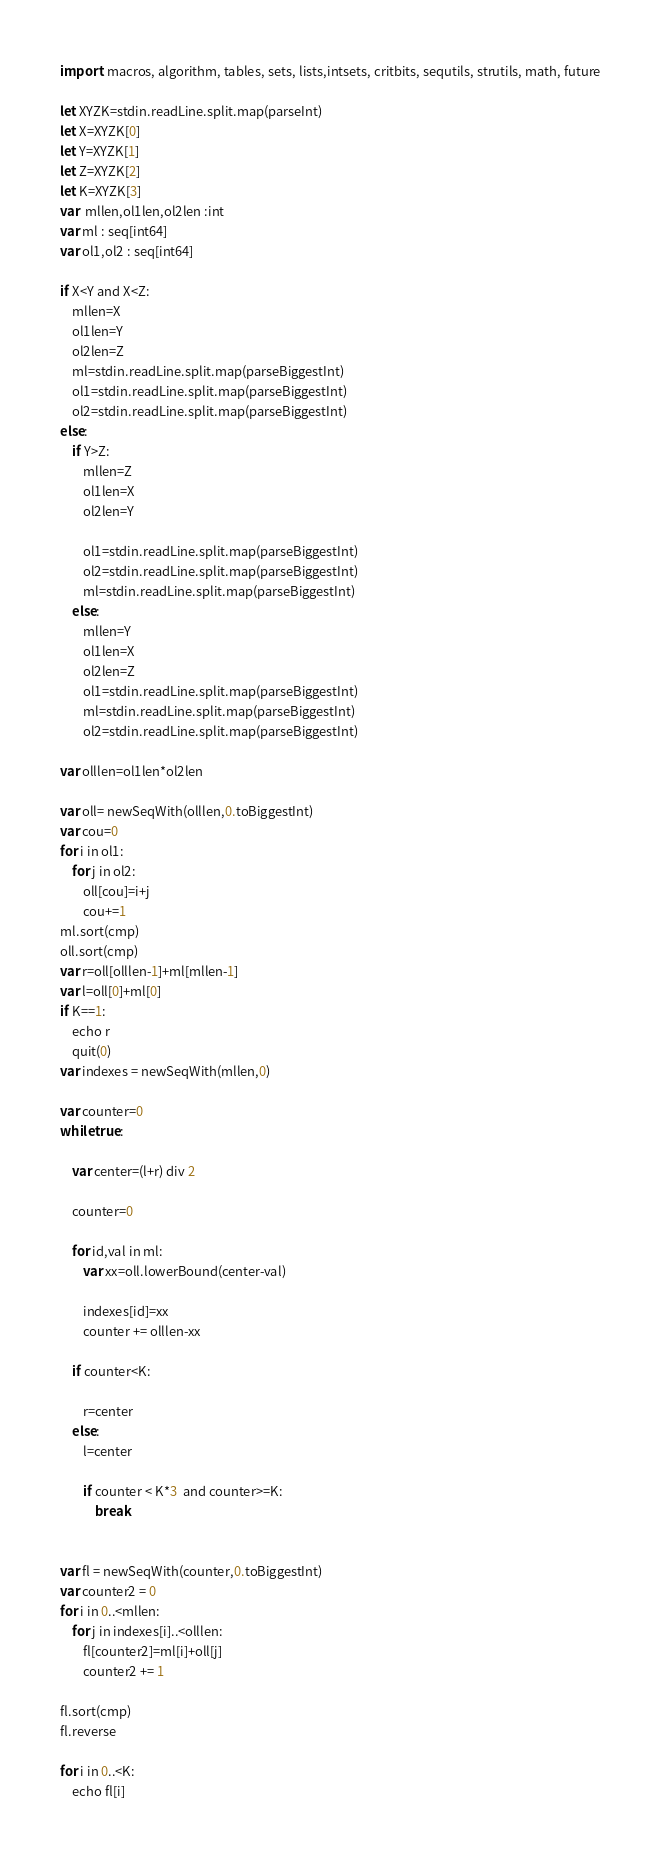<code> <loc_0><loc_0><loc_500><loc_500><_Nim_>import  macros, algorithm, tables, sets, lists,intsets, critbits, sequtils, strutils, math, future

let XYZK=stdin.readLine.split.map(parseInt)
let X=XYZK[0]
let Y=XYZK[1]
let Z=XYZK[2]
let K=XYZK[3]
var  mllen,ol1len,ol2len :int
var ml : seq[int64]
var ol1,ol2 : seq[int64]

if X<Y and X<Z:
    mllen=X
    ol1len=Y
    ol2len=Z
    ml=stdin.readLine.split.map(parseBiggestInt)
    ol1=stdin.readLine.split.map(parseBiggestInt)
    ol2=stdin.readLine.split.map(parseBiggestInt)
else:
    if Y>Z:
        mllen=Z
        ol1len=X
        ol2len=Y
   
        ol1=stdin.readLine.split.map(parseBiggestInt)
        ol2=stdin.readLine.split.map(parseBiggestInt)
        ml=stdin.readLine.split.map(parseBiggestInt)
    else:
        mllen=Y
        ol1len=X
        ol2len=Z
        ol1=stdin.readLine.split.map(parseBiggestInt)
        ml=stdin.readLine.split.map(parseBiggestInt)
        ol2=stdin.readLine.split.map(parseBiggestInt)

var olllen=ol1len*ol2len

var oll= newSeqWith(olllen,0.toBiggestInt)
var cou=0
for i in ol1:
    for j in ol2:
        oll[cou]=i+j
        cou+=1
ml.sort(cmp)
oll.sort(cmp)
var r=oll[olllen-1]+ml[mllen-1]
var l=oll[0]+ml[0]
if K==1:
    echo r
    quit(0)
var indexes = newSeqWith(mllen,0)

var counter=0
while true:

    var center=(l+r) div 2

    counter=0
    
    for id,val in ml:
        var xx=oll.lowerBound(center-val)

        indexes[id]=xx
        counter += olllen-xx

    if counter<K:

        r=center
    else:
        l=center
    
        if counter < K*3  and counter>=K:
            break 


var fl = newSeqWith(counter,0.toBiggestInt)
var counter2 = 0
for i in 0..<mllen:
    for j in indexes[i]..<olllen:
        fl[counter2]=ml[i]+oll[j]
        counter2 += 1

fl.sort(cmp)
fl.reverse

for i in 0..<K:
    echo fl[i]





















</code> 